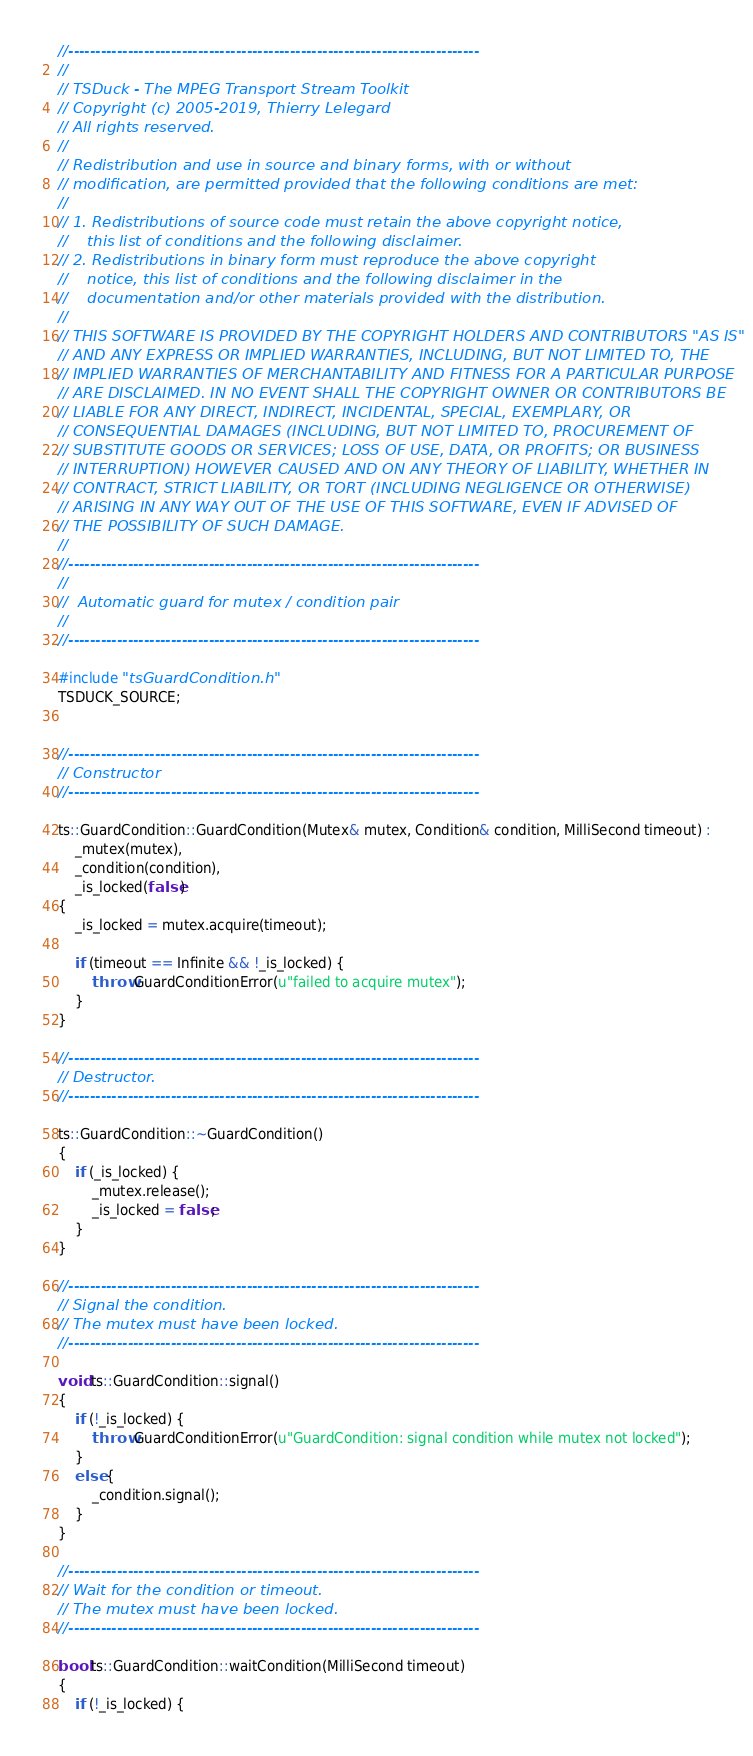Convert code to text. <code><loc_0><loc_0><loc_500><loc_500><_C++_>//----------------------------------------------------------------------------
//
// TSDuck - The MPEG Transport Stream Toolkit
// Copyright (c) 2005-2019, Thierry Lelegard
// All rights reserved.
//
// Redistribution and use in source and binary forms, with or without
// modification, are permitted provided that the following conditions are met:
//
// 1. Redistributions of source code must retain the above copyright notice,
//    this list of conditions and the following disclaimer.
// 2. Redistributions in binary form must reproduce the above copyright
//    notice, this list of conditions and the following disclaimer in the
//    documentation and/or other materials provided with the distribution.
//
// THIS SOFTWARE IS PROVIDED BY THE COPYRIGHT HOLDERS AND CONTRIBUTORS "AS IS"
// AND ANY EXPRESS OR IMPLIED WARRANTIES, INCLUDING, BUT NOT LIMITED TO, THE
// IMPLIED WARRANTIES OF MERCHANTABILITY AND FITNESS FOR A PARTICULAR PURPOSE
// ARE DISCLAIMED. IN NO EVENT SHALL THE COPYRIGHT OWNER OR CONTRIBUTORS BE
// LIABLE FOR ANY DIRECT, INDIRECT, INCIDENTAL, SPECIAL, EXEMPLARY, OR
// CONSEQUENTIAL DAMAGES (INCLUDING, BUT NOT LIMITED TO, PROCUREMENT OF
// SUBSTITUTE GOODS OR SERVICES; LOSS OF USE, DATA, OR PROFITS; OR BUSINESS
// INTERRUPTION) HOWEVER CAUSED AND ON ANY THEORY OF LIABILITY, WHETHER IN
// CONTRACT, STRICT LIABILITY, OR TORT (INCLUDING NEGLIGENCE OR OTHERWISE)
// ARISING IN ANY WAY OUT OF THE USE OF THIS SOFTWARE, EVEN IF ADVISED OF
// THE POSSIBILITY OF SUCH DAMAGE.
//
//----------------------------------------------------------------------------
//
//  Automatic guard for mutex / condition pair
//
//----------------------------------------------------------------------------

#include "tsGuardCondition.h"
TSDUCK_SOURCE;


//----------------------------------------------------------------------------
// Constructor
//----------------------------------------------------------------------------

ts::GuardCondition::GuardCondition(Mutex& mutex, Condition& condition, MilliSecond timeout) :
    _mutex(mutex),
    _condition(condition),
    _is_locked(false)
{
    _is_locked = mutex.acquire(timeout);

    if (timeout == Infinite && !_is_locked) {
        throw GuardConditionError(u"failed to acquire mutex");
    }
}

//----------------------------------------------------------------------------
// Destructor.
//----------------------------------------------------------------------------

ts::GuardCondition::~GuardCondition()
{
    if (_is_locked) {
        _mutex.release();
        _is_locked = false;
    }
}

//----------------------------------------------------------------------------
// Signal the condition.
// The mutex must have been locked.
//----------------------------------------------------------------------------

void ts::GuardCondition::signal()
{
    if (!_is_locked) {
        throw GuardConditionError(u"GuardCondition: signal condition while mutex not locked");
    }
    else {
        _condition.signal();
    }
}

//----------------------------------------------------------------------------
// Wait for the condition or timeout.
// The mutex must have been locked.
//----------------------------------------------------------------------------

bool ts::GuardCondition::waitCondition(MilliSecond timeout)
{
    if (!_is_locked) {</code> 